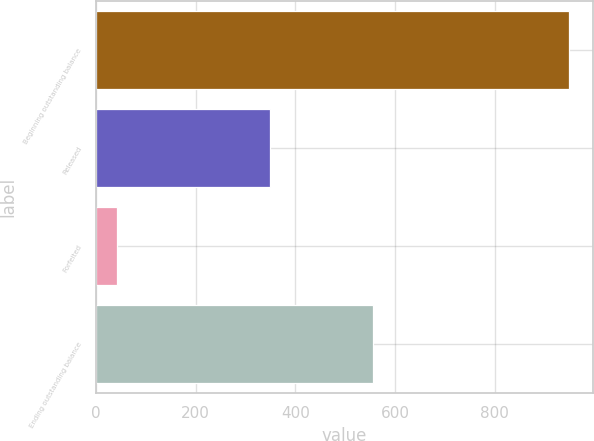<chart> <loc_0><loc_0><loc_500><loc_500><bar_chart><fcel>Beginning outstanding balance<fcel>Released<fcel>Forfeited<fcel>Ending outstanding balance<nl><fcel>950<fcel>350<fcel>43<fcel>557<nl></chart> 